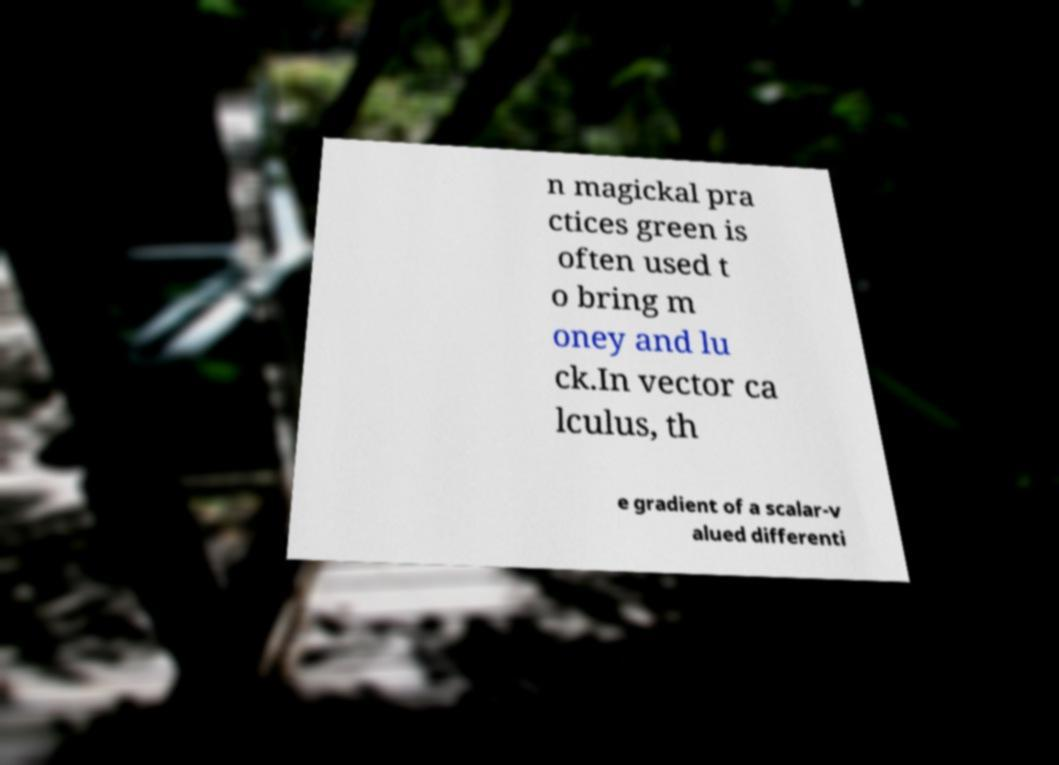Please read and relay the text visible in this image. What does it say? n magickal pra ctices green is often used t o bring m oney and lu ck.In vector ca lculus, th e gradient of a scalar-v alued differenti 